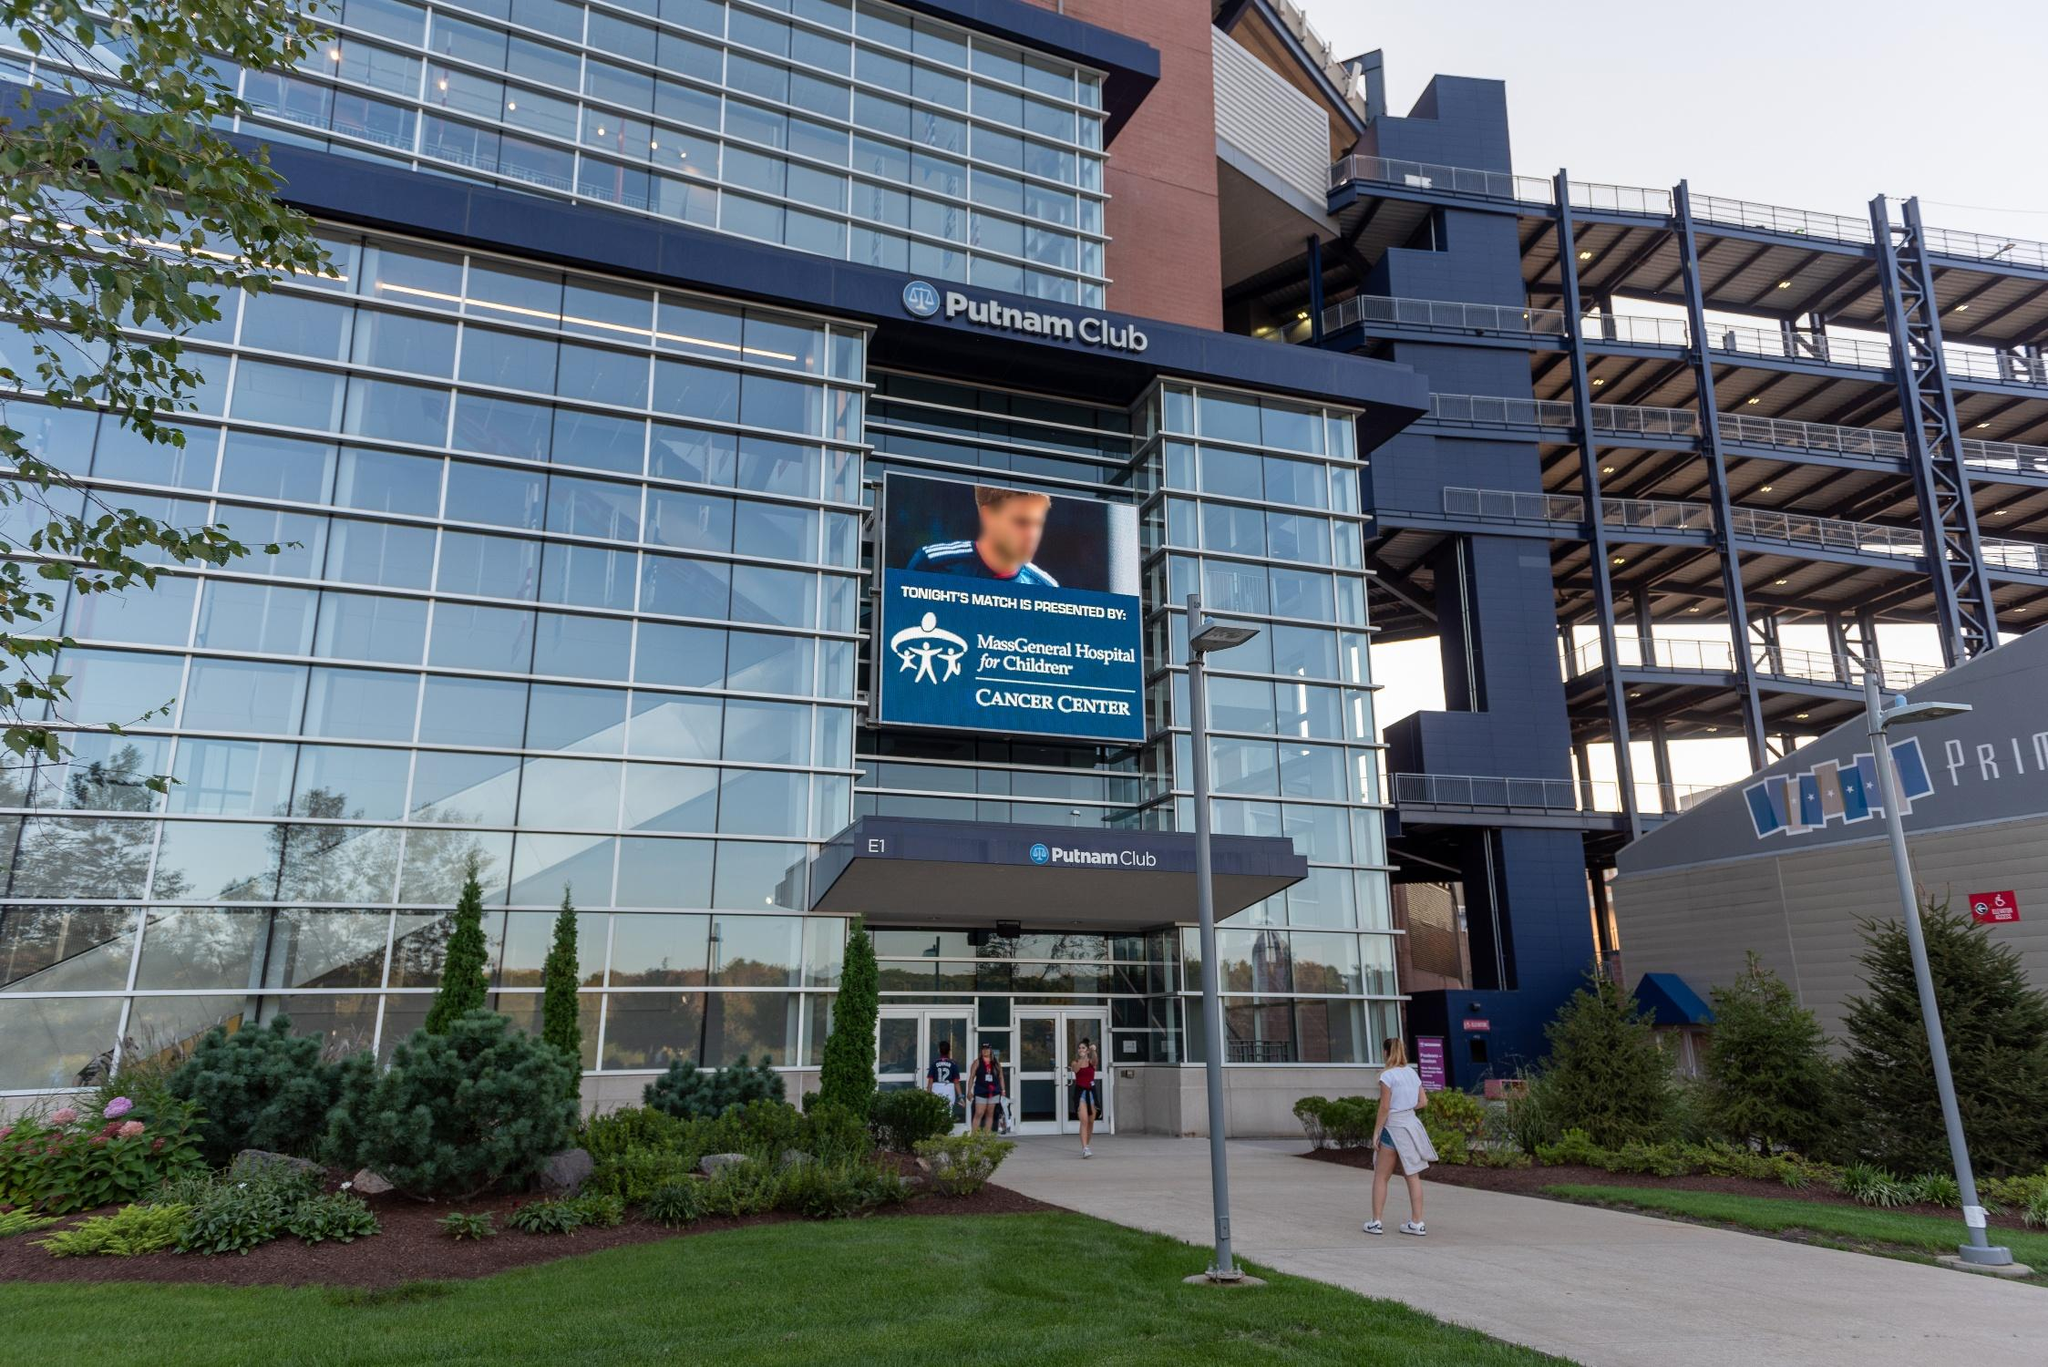Create a detailed narrative from the perspective of a visitor attending a significant event at this venue. Walking towards the Putnam Club, I am greeted by the gleaming glass façade reflecting the afternoon sky. The landscaped greenery around the entrance provides a calm and inviting atmosphere, contrasting with the anticipation bubbling inside me. As I step through the grand entrance, the state-of-the-art architectural design and the spacious lobby area immediately catch my eye. The large screen outside had already set the tone, displaying the importance of supporting health institutions, infusing a sense of purpose and community. Inside, the ambiance is lively with fans and event-goers mingling and chatting excitedly. The layout within the club is sophisticated yet comfortable, designed to enhance the overall experience with a touch of luxury. Screens and modern furniture fill the space, indicating the venue’s readiness to host a top-tier event. The positive energy is palpable, and I can’t help but look forward to an extraordinary experience at this esteemed venue. What specific elements contribute to the elegance and grandeur of the venue? Several elements contribute to the elegance and grandeur of the Putnam Club. The extensive use of glass in the façade creates a sleek, modern look, allowing natural light to flood the interior while offering stunning reflections of the sky. The steel framework adds a touch of industrial chic, providing both structural integrity and visual appeal. The meticulous landscaping surrounding the entrance, with well-maintained greenery, enhances the building’s aesthetic and hospitality. Inside, the design emphasizes spaciousness and luxury, with high ceilings, contemporary furnishings, and advanced technology integrated seamlessly. These features collectively contribute to an upscale and grand visitor experience. Imagine a day in the life of the Putnam Club; describe a full day’s itinerary. A day at the Putnam Club begins early, with staff arriving to prepare for the day’s events. The morning starts with a thorough inspection and maintenance routine, ensuring the venue is pristine and all systems are functioning perfectly. As the sun rises, the glass façade glistens, welcoming the first wave of visitors who might be attending a morning business conference. The venue transitions seamlessly from formal to casual as the day progresses. Midday might see a flurry of activity as attendees of a corporate luncheon arrive, utilizing the high-end dining facilities and enjoying a meticulously catered meal. Throughout the afternoon, sports enthusiasts begin to trickle in, perhaps for a late afternoon game or concert. The ambiance shifts to excitement and energy as fans flock to the state-of-the-art lounge areas, enjoying refreshments and socializing. By evening, the venue is at its peak capacity, buzzing with fans and event-goers. The large digital screen displays event-related content, building anticipation. The night concludes with satisfied visitors departing, and the venue undergoes a meticulous clean-up. The day ends as it began, with staff ensuring everything is in order for another day of exemplary service and unforgettable experiences. 